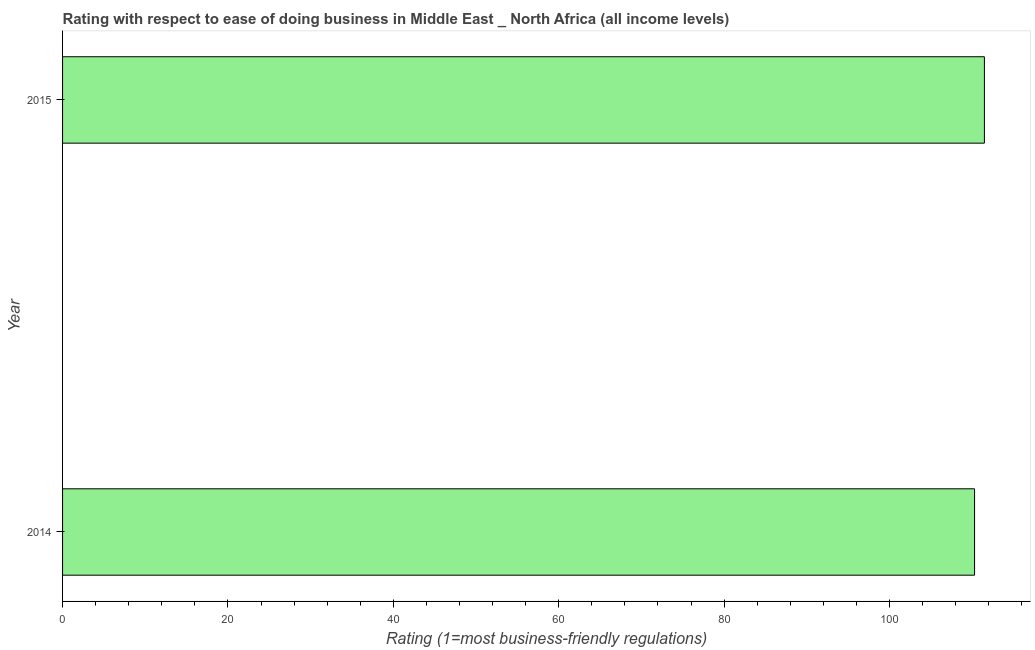Does the graph contain any zero values?
Keep it short and to the point. No. Does the graph contain grids?
Provide a succinct answer. No. What is the title of the graph?
Offer a terse response. Rating with respect to ease of doing business in Middle East _ North Africa (all income levels). What is the label or title of the X-axis?
Keep it short and to the point. Rating (1=most business-friendly regulations). What is the label or title of the Y-axis?
Your answer should be compact. Year. What is the ease of doing business index in 2014?
Ensure brevity in your answer.  110.29. Across all years, what is the maximum ease of doing business index?
Your answer should be very brief. 111.48. Across all years, what is the minimum ease of doing business index?
Your answer should be very brief. 110.29. In which year was the ease of doing business index maximum?
Your answer should be compact. 2015. What is the sum of the ease of doing business index?
Offer a terse response. 221.76. What is the difference between the ease of doing business index in 2014 and 2015?
Your response must be concise. -1.19. What is the average ease of doing business index per year?
Make the answer very short. 110.88. What is the median ease of doing business index?
Make the answer very short. 110.88. In how many years, is the ease of doing business index greater than 28 ?
Your response must be concise. 2. Do a majority of the years between 2015 and 2014 (inclusive) have ease of doing business index greater than 20 ?
Keep it short and to the point. No. How many bars are there?
Make the answer very short. 2. How many years are there in the graph?
Make the answer very short. 2. Are the values on the major ticks of X-axis written in scientific E-notation?
Your answer should be very brief. No. What is the Rating (1=most business-friendly regulations) of 2014?
Ensure brevity in your answer.  110.29. What is the Rating (1=most business-friendly regulations) in 2015?
Your response must be concise. 111.48. What is the difference between the Rating (1=most business-friendly regulations) in 2014 and 2015?
Make the answer very short. -1.19. 